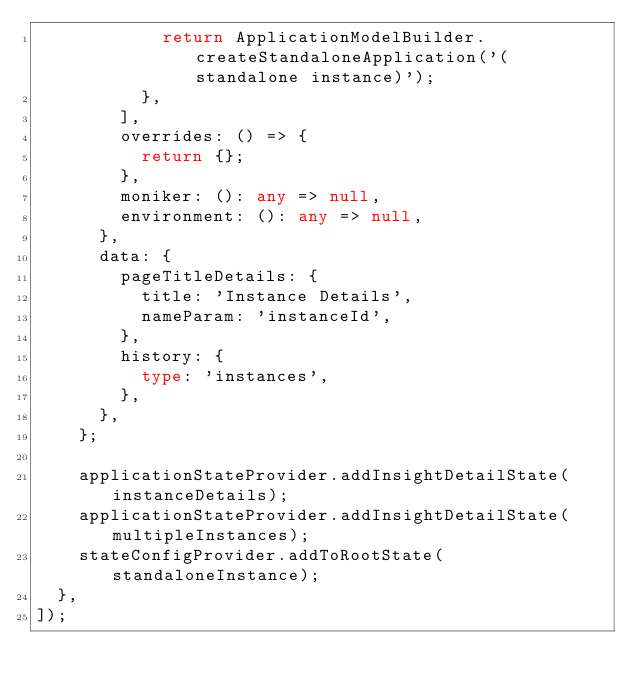<code> <loc_0><loc_0><loc_500><loc_500><_TypeScript_>            return ApplicationModelBuilder.createStandaloneApplication('(standalone instance)');
          },
        ],
        overrides: () => {
          return {};
        },
        moniker: (): any => null,
        environment: (): any => null,
      },
      data: {
        pageTitleDetails: {
          title: 'Instance Details',
          nameParam: 'instanceId',
        },
        history: {
          type: 'instances',
        },
      },
    };

    applicationStateProvider.addInsightDetailState(instanceDetails);
    applicationStateProvider.addInsightDetailState(multipleInstances);
    stateConfigProvider.addToRootState(standaloneInstance);
  },
]);
</code> 